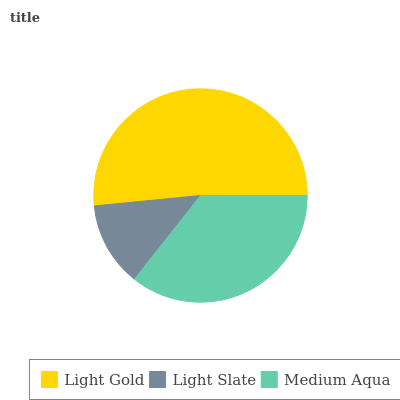Is Light Slate the minimum?
Answer yes or no. Yes. Is Light Gold the maximum?
Answer yes or no. Yes. Is Medium Aqua the minimum?
Answer yes or no. No. Is Medium Aqua the maximum?
Answer yes or no. No. Is Medium Aqua greater than Light Slate?
Answer yes or no. Yes. Is Light Slate less than Medium Aqua?
Answer yes or no. Yes. Is Light Slate greater than Medium Aqua?
Answer yes or no. No. Is Medium Aqua less than Light Slate?
Answer yes or no. No. Is Medium Aqua the high median?
Answer yes or no. Yes. Is Medium Aqua the low median?
Answer yes or no. Yes. Is Light Gold the high median?
Answer yes or no. No. Is Light Slate the low median?
Answer yes or no. No. 